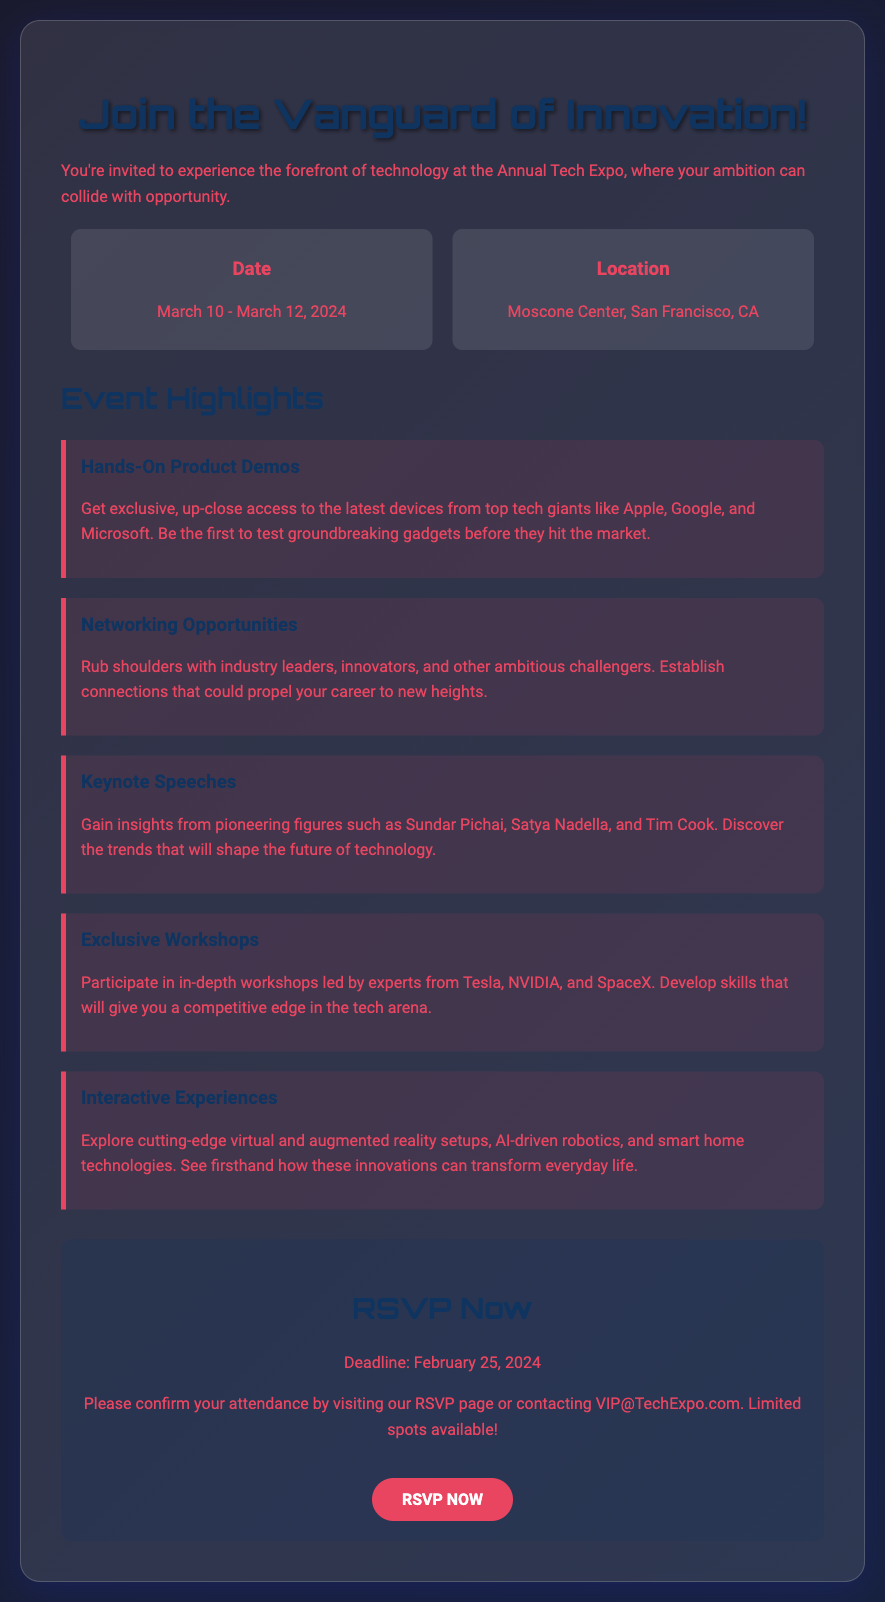What are the event dates? The event dates are mentioned in the document as March 10 - March 12, 2024.
Answer: March 10 - March 12, 2024 Where is the event located? The location of the event is specified as Moscone Center, San Francisco, CA.
Answer: Moscone Center, San Francisco, CA What is one of the event highlights? The document lists several highlights, one of them is "Hands-On Product Demos."
Answer: Hands-On Product Demos Who is the keynote speaker mentioned? One of the keynote speakers mentioned in the document is Sundar Pichai.
Answer: Sundar Pichai What is the RSVP deadline? The document clearly states that the RSVP deadline is February 25, 2024.
Answer: February 25, 2024 How can attendees confirm their attendance? The document advises confirming attendance by visiting the RSVP page or contacting VIP@TechExpo.com.
Answer: VIP@TechExpo.com What type of experiences will be interactive? The document notes that virtual and augmented reality setups will be interactive experiences.
Answer: Virtual and augmented reality What should you do to RSVP? The document indicates that attendees can RSVP by visiting the RSVP page or using the "RSVP NOW" button.
Answer: RSVP NOW What is a benefit of networking at the event? The networking opportunities provide a chance to establish connections that could propel your career.
Answer: Propel your career 